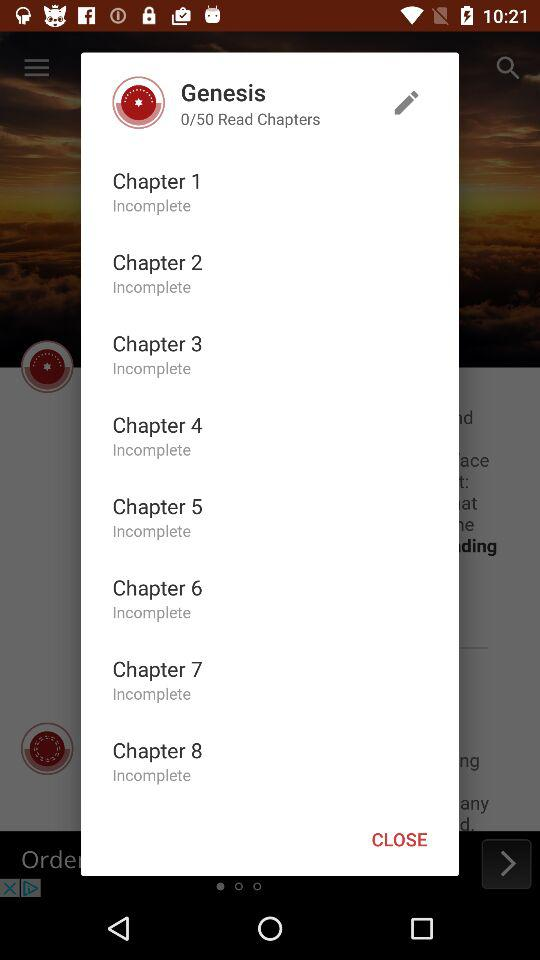How many chapters have been read?
Answer the question using a single word or phrase. 0 